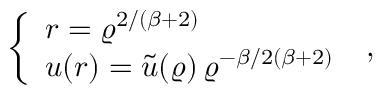Convert formula to latex. <formula><loc_0><loc_0><loc_500><loc_500>\left \{ \begin{array} { l } { { r = \varrho ^ { 2 / ( \beta + 2 ) } } } \\ { { u ( r ) = \widetilde { u } ( \varrho ) \, \varrho ^ { - \beta / 2 ( \beta + 2 ) } } } \end{array} \, ,</formula> 